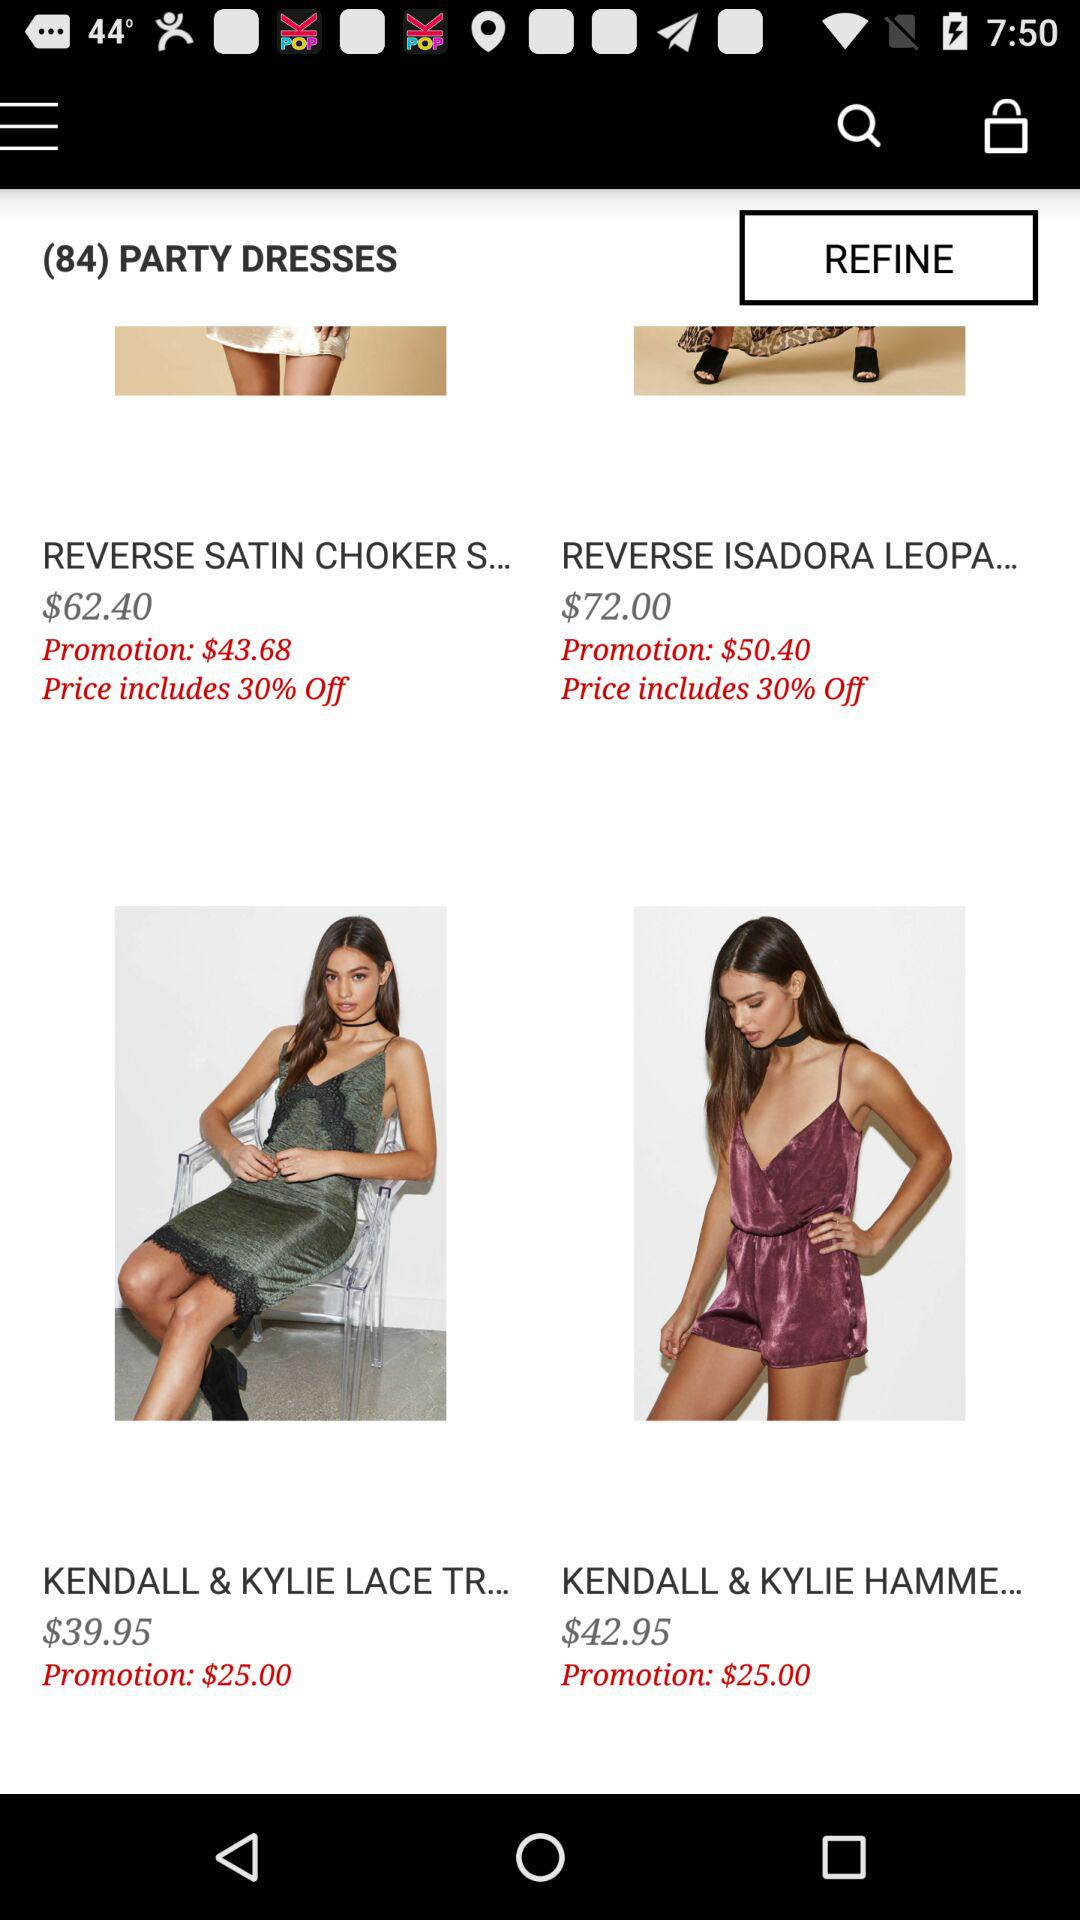How much is the promotion price of "REVERSE ISADORA LEOPA..."? The promotion price of "REVERSE ISADORA LEOPA..." is 50.40 dollars. 